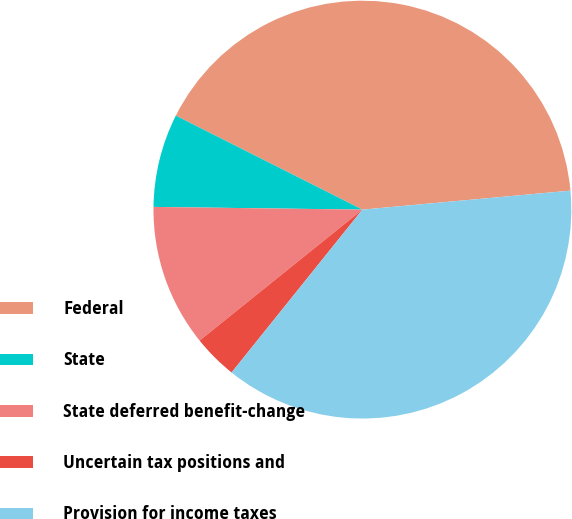Convert chart to OTSL. <chart><loc_0><loc_0><loc_500><loc_500><pie_chart><fcel>Federal<fcel>State<fcel>State deferred benefit-change<fcel>Uncertain tax positions and<fcel>Provision for income taxes<nl><fcel>41.13%<fcel>7.22%<fcel>10.99%<fcel>3.45%<fcel>37.22%<nl></chart> 